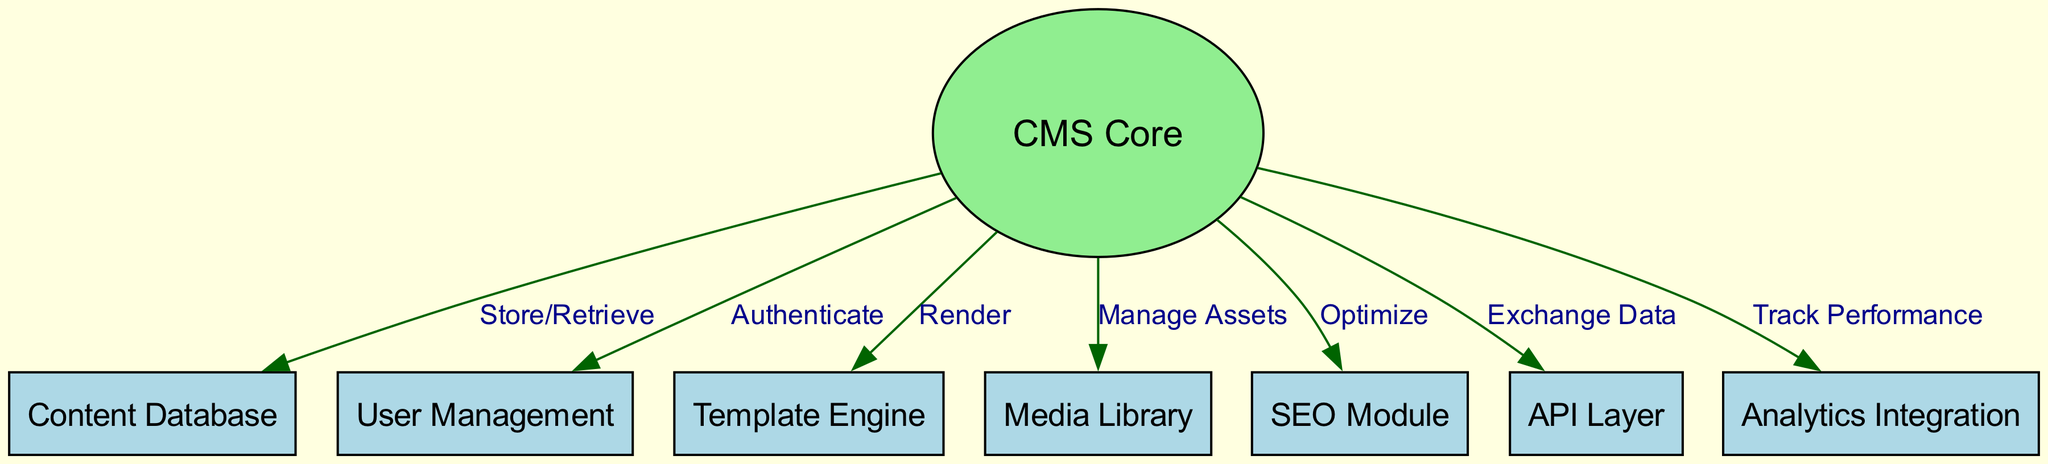What is the number of nodes in the diagram? The diagram lists out a total of 8 individual nodes, which include CMS Core, Content Database, User Management, Template Engine, Media Library, SEO Module, API Layer, and Analytics Integration.
Answer: 8 What is the relationship between CMS Core and Content Database? The diagram indicates that CMS Core has a direct connection to Content Database, labeled as "Store/Retrieve," which shows the data flow for storing and retrieving content.
Answer: Store/Retrieve Which module is responsible for authenticating users? The User Management node connects to CMS Core as indicated by the edge labeled "Authenticate." This signifies that the User Management module facilitates user authentication for the CMS.
Answer: User Management How many edges connect to CMS Core? There are 6 edges connecting to CMS Core, representing the relationships with each of the other modules: Content Database, User Management, Template Engine, Media Library, SEO Module, API Layer, and Analytics Integration.
Answer: 6 What does the Template Engine do in the CMS architecture? The Template Engine is connected to CMS Core through an edge labeled "Render," indicating its function is to render the content that is processed by the core of the CMS.
Answer: Render Which module does CMS Core interact with for performance tracking? The Analytics Integration node is connected to CMS Core through an edge labeled "Track Performance." This establishes that CMS Core engages Analytics Integration to track the overall performance of the content.
Answer: Analytics Integration Which module is responsible for optimizing the content? The SEO Module links to CMS Core with an edge labeled "Optimize," indicating that this module plays a role in the optimization of content within the CMS architecture.
Answer: SEO Module What type of data exchange occurs between CMS Core and API Layer? The edge between CMS Core and API Layer is labeled "Exchange Data," signifying that these components are involved in exchanging data, possibly for integration with external services or applications.
Answer: Exchange Data What is the purpose of the Media Library in the diagram? The Media Library connects to CMS Core and is labeled as "Manage Assets," showing that its purpose is to manage media assets such as images and videos used on the site.
Answer: Manage Assets 